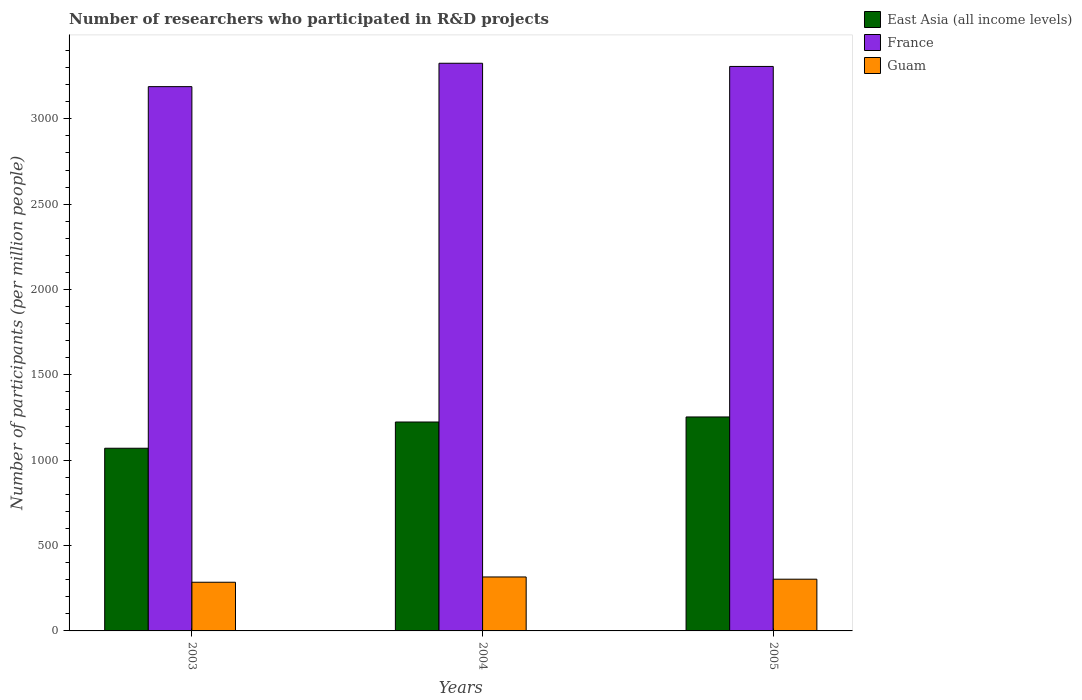Are the number of bars on each tick of the X-axis equal?
Offer a terse response. Yes. What is the number of researchers who participated in R&D projects in East Asia (all income levels) in 2003?
Your answer should be compact. 1070.1. Across all years, what is the maximum number of researchers who participated in R&D projects in Guam?
Make the answer very short. 316.07. Across all years, what is the minimum number of researchers who participated in R&D projects in East Asia (all income levels)?
Your answer should be compact. 1070.1. In which year was the number of researchers who participated in R&D projects in France minimum?
Your answer should be compact. 2003. What is the total number of researchers who participated in R&D projects in East Asia (all income levels) in the graph?
Keep it short and to the point. 3547.31. What is the difference between the number of researchers who participated in R&D projects in France in 2003 and that in 2005?
Provide a succinct answer. -118.22. What is the difference between the number of researchers who participated in R&D projects in East Asia (all income levels) in 2005 and the number of researchers who participated in R&D projects in France in 2004?
Your answer should be very brief. -2071.94. What is the average number of researchers who participated in R&D projects in East Asia (all income levels) per year?
Keep it short and to the point. 1182.44. In the year 2005, what is the difference between the number of researchers who participated in R&D projects in France and number of researchers who participated in R&D projects in Guam?
Ensure brevity in your answer.  3003.65. In how many years, is the number of researchers who participated in R&D projects in Guam greater than 3000?
Provide a short and direct response. 0. What is the ratio of the number of researchers who participated in R&D projects in France in 2004 to that in 2005?
Your response must be concise. 1.01. Is the number of researchers who participated in R&D projects in Guam in 2004 less than that in 2005?
Provide a short and direct response. No. Is the difference between the number of researchers who participated in R&D projects in France in 2004 and 2005 greater than the difference between the number of researchers who participated in R&D projects in Guam in 2004 and 2005?
Your response must be concise. Yes. What is the difference between the highest and the second highest number of researchers who participated in R&D projects in France?
Provide a short and direct response. 18.68. What is the difference between the highest and the lowest number of researchers who participated in R&D projects in Guam?
Ensure brevity in your answer.  30.94. In how many years, is the number of researchers who participated in R&D projects in East Asia (all income levels) greater than the average number of researchers who participated in R&D projects in East Asia (all income levels) taken over all years?
Your answer should be very brief. 2. What does the 2nd bar from the right in 2004 represents?
Provide a short and direct response. France. Are the values on the major ticks of Y-axis written in scientific E-notation?
Offer a terse response. No. Does the graph contain any zero values?
Offer a very short reply. No. Where does the legend appear in the graph?
Provide a succinct answer. Top right. How many legend labels are there?
Offer a very short reply. 3. How are the legend labels stacked?
Make the answer very short. Vertical. What is the title of the graph?
Offer a terse response. Number of researchers who participated in R&D projects. What is the label or title of the Y-axis?
Provide a succinct answer. Number of participants (per million people). What is the Number of participants (per million people) in East Asia (all income levels) in 2003?
Provide a succinct answer. 1070.1. What is the Number of participants (per million people) in France in 2003?
Your response must be concise. 3188.46. What is the Number of participants (per million people) of Guam in 2003?
Your answer should be compact. 285.13. What is the Number of participants (per million people) in East Asia (all income levels) in 2004?
Make the answer very short. 1223.79. What is the Number of participants (per million people) in France in 2004?
Make the answer very short. 3325.36. What is the Number of participants (per million people) in Guam in 2004?
Provide a succinct answer. 316.07. What is the Number of participants (per million people) in East Asia (all income levels) in 2005?
Provide a succinct answer. 1253.42. What is the Number of participants (per million people) of France in 2005?
Give a very brief answer. 3306.68. What is the Number of participants (per million people) of Guam in 2005?
Provide a short and direct response. 303.03. Across all years, what is the maximum Number of participants (per million people) of East Asia (all income levels)?
Your response must be concise. 1253.42. Across all years, what is the maximum Number of participants (per million people) in France?
Offer a very short reply. 3325.36. Across all years, what is the maximum Number of participants (per million people) of Guam?
Keep it short and to the point. 316.07. Across all years, what is the minimum Number of participants (per million people) of East Asia (all income levels)?
Make the answer very short. 1070.1. Across all years, what is the minimum Number of participants (per million people) of France?
Provide a succinct answer. 3188.46. Across all years, what is the minimum Number of participants (per million people) of Guam?
Ensure brevity in your answer.  285.13. What is the total Number of participants (per million people) of East Asia (all income levels) in the graph?
Give a very brief answer. 3547.31. What is the total Number of participants (per million people) in France in the graph?
Your response must be concise. 9820.51. What is the total Number of participants (per million people) of Guam in the graph?
Make the answer very short. 904.23. What is the difference between the Number of participants (per million people) in East Asia (all income levels) in 2003 and that in 2004?
Your answer should be compact. -153.69. What is the difference between the Number of participants (per million people) of France in 2003 and that in 2004?
Offer a terse response. -136.9. What is the difference between the Number of participants (per million people) in Guam in 2003 and that in 2004?
Offer a terse response. -30.94. What is the difference between the Number of participants (per million people) of East Asia (all income levels) in 2003 and that in 2005?
Provide a succinct answer. -183.32. What is the difference between the Number of participants (per million people) of France in 2003 and that in 2005?
Ensure brevity in your answer.  -118.22. What is the difference between the Number of participants (per million people) in Guam in 2003 and that in 2005?
Ensure brevity in your answer.  -17.9. What is the difference between the Number of participants (per million people) of East Asia (all income levels) in 2004 and that in 2005?
Ensure brevity in your answer.  -29.63. What is the difference between the Number of participants (per million people) of France in 2004 and that in 2005?
Your response must be concise. 18.68. What is the difference between the Number of participants (per million people) of Guam in 2004 and that in 2005?
Ensure brevity in your answer.  13.04. What is the difference between the Number of participants (per million people) in East Asia (all income levels) in 2003 and the Number of participants (per million people) in France in 2004?
Give a very brief answer. -2255.27. What is the difference between the Number of participants (per million people) of East Asia (all income levels) in 2003 and the Number of participants (per million people) of Guam in 2004?
Give a very brief answer. 754.03. What is the difference between the Number of participants (per million people) of France in 2003 and the Number of participants (per million people) of Guam in 2004?
Your response must be concise. 2872.39. What is the difference between the Number of participants (per million people) in East Asia (all income levels) in 2003 and the Number of participants (per million people) in France in 2005?
Provide a succinct answer. -2236.58. What is the difference between the Number of participants (per million people) in East Asia (all income levels) in 2003 and the Number of participants (per million people) in Guam in 2005?
Ensure brevity in your answer.  767.07. What is the difference between the Number of participants (per million people) in France in 2003 and the Number of participants (per million people) in Guam in 2005?
Keep it short and to the point. 2885.43. What is the difference between the Number of participants (per million people) in East Asia (all income levels) in 2004 and the Number of participants (per million people) in France in 2005?
Your response must be concise. -2082.89. What is the difference between the Number of participants (per million people) in East Asia (all income levels) in 2004 and the Number of participants (per million people) in Guam in 2005?
Provide a succinct answer. 920.76. What is the difference between the Number of participants (per million people) of France in 2004 and the Number of participants (per million people) of Guam in 2005?
Your response must be concise. 3022.34. What is the average Number of participants (per million people) in East Asia (all income levels) per year?
Provide a succinct answer. 1182.44. What is the average Number of participants (per million people) of France per year?
Ensure brevity in your answer.  3273.5. What is the average Number of participants (per million people) in Guam per year?
Offer a very short reply. 301.41. In the year 2003, what is the difference between the Number of participants (per million people) of East Asia (all income levels) and Number of participants (per million people) of France?
Your answer should be very brief. -2118.36. In the year 2003, what is the difference between the Number of participants (per million people) in East Asia (all income levels) and Number of participants (per million people) in Guam?
Your response must be concise. 784.97. In the year 2003, what is the difference between the Number of participants (per million people) in France and Number of participants (per million people) in Guam?
Your answer should be very brief. 2903.33. In the year 2004, what is the difference between the Number of participants (per million people) of East Asia (all income levels) and Number of participants (per million people) of France?
Keep it short and to the point. -2101.58. In the year 2004, what is the difference between the Number of participants (per million people) of East Asia (all income levels) and Number of participants (per million people) of Guam?
Your answer should be compact. 907.72. In the year 2004, what is the difference between the Number of participants (per million people) of France and Number of participants (per million people) of Guam?
Provide a short and direct response. 3009.3. In the year 2005, what is the difference between the Number of participants (per million people) in East Asia (all income levels) and Number of participants (per million people) in France?
Provide a short and direct response. -2053.26. In the year 2005, what is the difference between the Number of participants (per million people) in East Asia (all income levels) and Number of participants (per million people) in Guam?
Offer a very short reply. 950.39. In the year 2005, what is the difference between the Number of participants (per million people) in France and Number of participants (per million people) in Guam?
Ensure brevity in your answer.  3003.65. What is the ratio of the Number of participants (per million people) in East Asia (all income levels) in 2003 to that in 2004?
Your answer should be very brief. 0.87. What is the ratio of the Number of participants (per million people) in France in 2003 to that in 2004?
Offer a terse response. 0.96. What is the ratio of the Number of participants (per million people) of Guam in 2003 to that in 2004?
Provide a short and direct response. 0.9. What is the ratio of the Number of participants (per million people) of East Asia (all income levels) in 2003 to that in 2005?
Offer a very short reply. 0.85. What is the ratio of the Number of participants (per million people) of France in 2003 to that in 2005?
Give a very brief answer. 0.96. What is the ratio of the Number of participants (per million people) of Guam in 2003 to that in 2005?
Your answer should be compact. 0.94. What is the ratio of the Number of participants (per million people) of East Asia (all income levels) in 2004 to that in 2005?
Provide a succinct answer. 0.98. What is the ratio of the Number of participants (per million people) in Guam in 2004 to that in 2005?
Your answer should be compact. 1.04. What is the difference between the highest and the second highest Number of participants (per million people) of East Asia (all income levels)?
Make the answer very short. 29.63. What is the difference between the highest and the second highest Number of participants (per million people) of France?
Provide a succinct answer. 18.68. What is the difference between the highest and the second highest Number of participants (per million people) of Guam?
Provide a succinct answer. 13.04. What is the difference between the highest and the lowest Number of participants (per million people) of East Asia (all income levels)?
Provide a short and direct response. 183.32. What is the difference between the highest and the lowest Number of participants (per million people) in France?
Provide a succinct answer. 136.9. What is the difference between the highest and the lowest Number of participants (per million people) in Guam?
Provide a succinct answer. 30.94. 